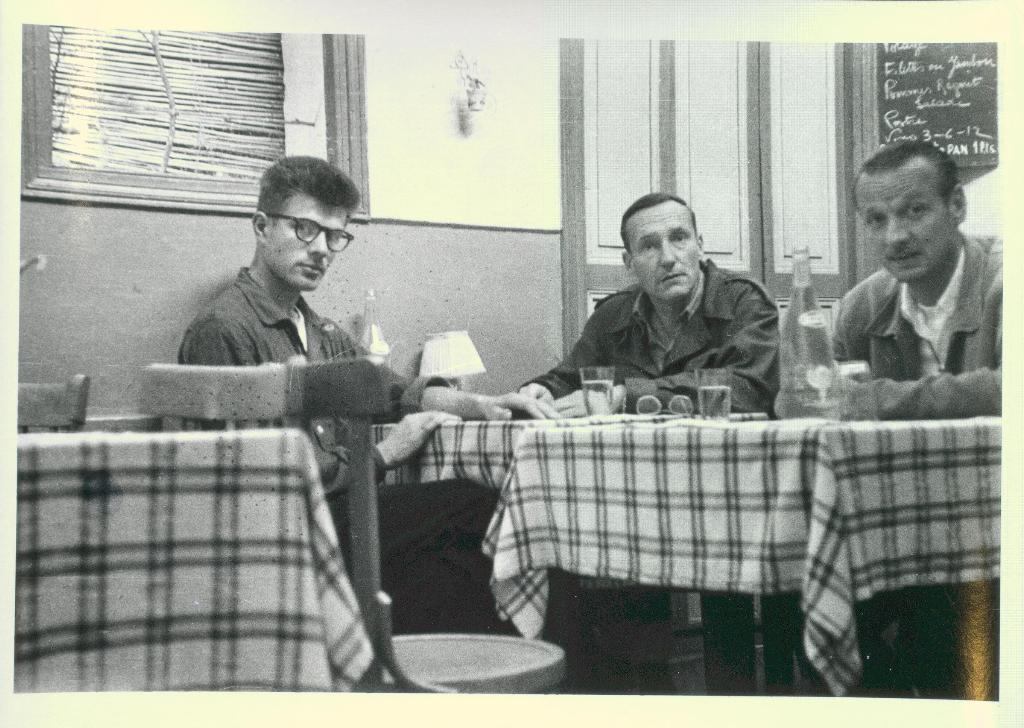How many people are present in the image? There are three people in the image. What are the people doing in the image? The people are sitting near a table. What objects can be seen on the table? There are two glasses and a glass bottle on the table. What architectural features can be seen in the background of the image? There is a door, a wall, and a curtain in the background of the image. What type of writing can be seen on the curtain in the image? There is no writing visible on the curtain in the image. Can you see any insects crawling on the table in the image? There are no insects present in the image. 